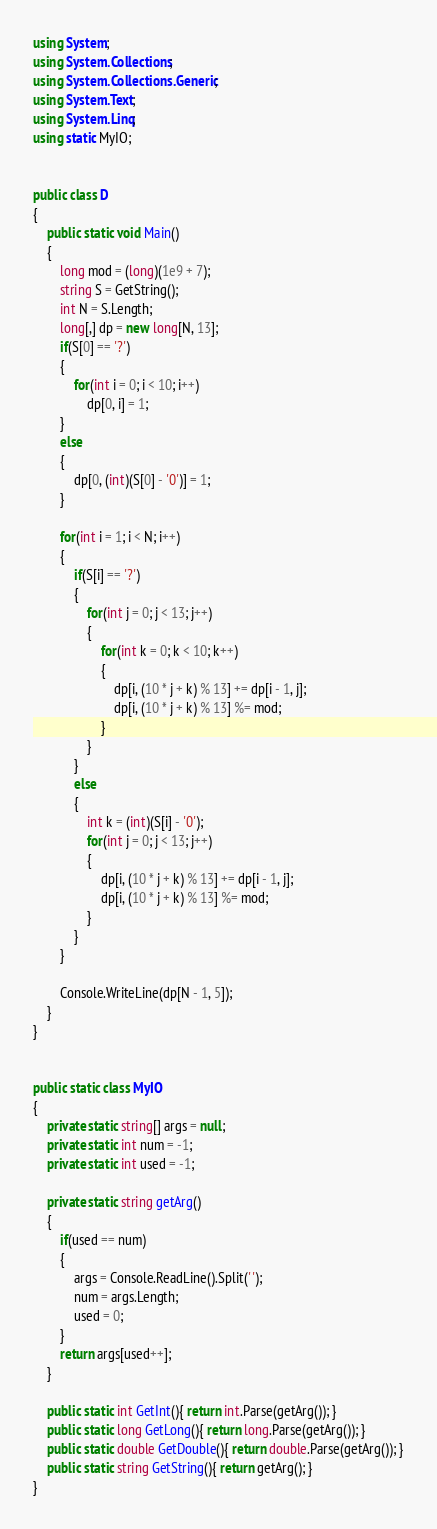<code> <loc_0><loc_0><loc_500><loc_500><_C#_>using System;
using System.Collections;
using System.Collections.Generic;
using System.Text;
using System.Linq;
using static MyIO;


public class D
{
	public static void Main()
	{
		long mod = (long)(1e9 + 7);
		string S = GetString();
		int N = S.Length;
		long[,] dp = new long[N, 13];
		if(S[0] == '?')
		{
			for(int i = 0; i < 10; i++)
				dp[0, i] = 1;
		}
		else
		{
			dp[0, (int)(S[0] - '0')] = 1;
		}

		for(int i = 1; i < N; i++)
		{
			if(S[i] == '?')
			{
				for(int j = 0; j < 13; j++)
				{
					for(int k = 0; k < 10; k++)
					{
						dp[i, (10 * j + k) % 13] += dp[i - 1, j];
						dp[i, (10 * j + k) % 13] %= mod;
					}
				}
			}
			else
			{
				int k = (int)(S[i] - '0');
				for(int j = 0; j < 13; j++)
				{
					dp[i, (10 * j + k) % 13] += dp[i - 1, j];
					dp[i, (10 * j + k) % 13] %= mod;
				}
			}
		}

		Console.WriteLine(dp[N - 1, 5]);
	}
}


public static class MyIO
{
	private static string[] args = null;
	private static int num = -1;
	private static int used = -1;

	private static string getArg()
	{
		if(used == num)
		{
			args = Console.ReadLine().Split(' ');
			num = args.Length;
			used = 0;
		}
		return args[used++];
	}

	public static int GetInt(){ return int.Parse(getArg()); }
	public static long GetLong(){ return long.Parse(getArg()); }
	public static double GetDouble(){ return double.Parse(getArg()); }
	public static string GetString(){ return getArg(); }
}



</code> 